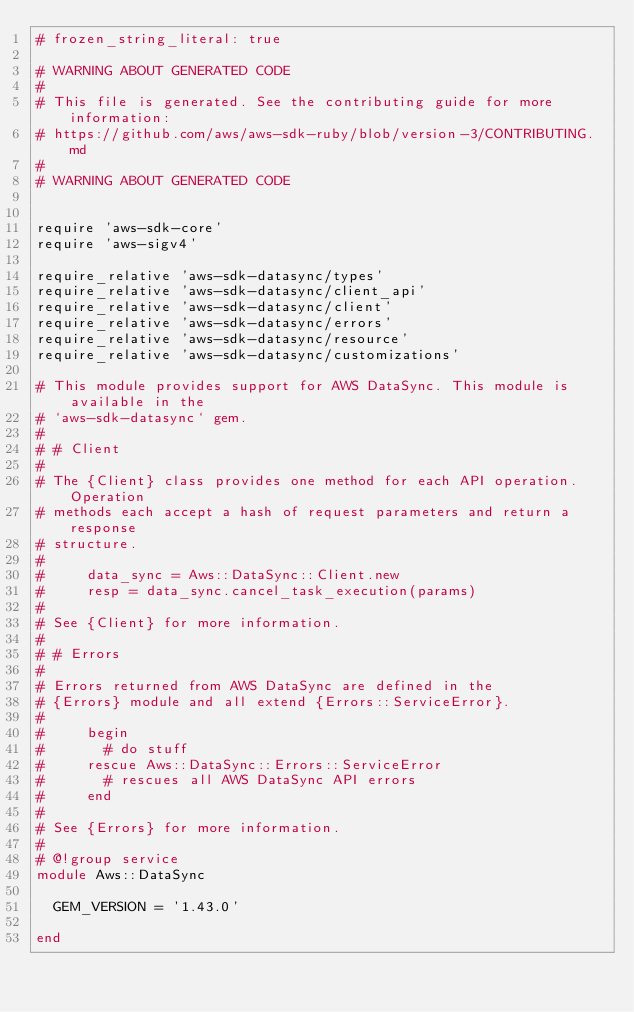<code> <loc_0><loc_0><loc_500><loc_500><_Ruby_># frozen_string_literal: true

# WARNING ABOUT GENERATED CODE
#
# This file is generated. See the contributing guide for more information:
# https://github.com/aws/aws-sdk-ruby/blob/version-3/CONTRIBUTING.md
#
# WARNING ABOUT GENERATED CODE


require 'aws-sdk-core'
require 'aws-sigv4'

require_relative 'aws-sdk-datasync/types'
require_relative 'aws-sdk-datasync/client_api'
require_relative 'aws-sdk-datasync/client'
require_relative 'aws-sdk-datasync/errors'
require_relative 'aws-sdk-datasync/resource'
require_relative 'aws-sdk-datasync/customizations'

# This module provides support for AWS DataSync. This module is available in the
# `aws-sdk-datasync` gem.
#
# # Client
#
# The {Client} class provides one method for each API operation. Operation
# methods each accept a hash of request parameters and return a response
# structure.
#
#     data_sync = Aws::DataSync::Client.new
#     resp = data_sync.cancel_task_execution(params)
#
# See {Client} for more information.
#
# # Errors
#
# Errors returned from AWS DataSync are defined in the
# {Errors} module and all extend {Errors::ServiceError}.
#
#     begin
#       # do stuff
#     rescue Aws::DataSync::Errors::ServiceError
#       # rescues all AWS DataSync API errors
#     end
#
# See {Errors} for more information.
#
# @!group service
module Aws::DataSync

  GEM_VERSION = '1.43.0'

end
</code> 